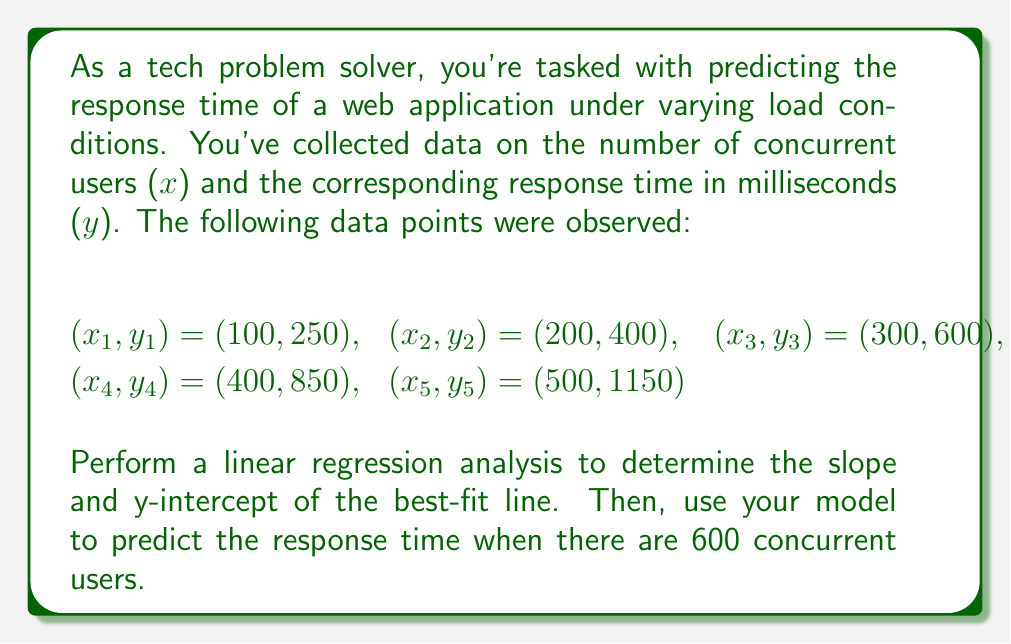What is the answer to this math problem? To perform linear regression, we'll use the least squares method to find the best-fit line $y = mx + b$, where $m$ is the slope and $b$ is the y-intercept.

Step 1: Calculate the means of x and y
$$\bar{x} = \frac{100 + 200 + 300 + 400 + 500}{5} = 300$$
$$\bar{y} = \frac{250 + 400 + 600 + 850 + 1150}{5} = 650$$

Step 2: Calculate the slope (m)
$$m = \frac{\sum(x_i - \bar{x})(y_i - \bar{y})}{\sum(x_i - \bar{x})^2}$$

Calculate the numerator and denominator:
$$(100 - 300)(250 - 650) + (200 - 300)(400 - 650) + (300 - 300)(600 - 650) + (400 - 300)(850 - 650) + (500 - 300)(1150 - 650)$$
$$= 80000 + 25000 + 0 + 40000 + 100000 = 245000$$

$$(100 - 300)^2 + (200 - 300)^2 + (300 - 300)^2 + (400 - 300)^2 + (500 - 300)^2$$
$$= 40000 + 10000 + 0 + 10000 + 40000 = 100000$$

$$m = \frac{245000}{100000} = 2.45$$

Step 3: Calculate the y-intercept (b)
$$b = \bar{y} - m\bar{x} = 650 - 2.45(300) = -85$$

Step 4: Write the equation of the best-fit line
$$y = 2.45x - 85$$

Step 5: Predict the response time for 600 concurrent users
$$y = 2.45(600) - 85 = 1385$$

Therefore, the predicted response time for 600 concurrent users is 1385 milliseconds.
Answer: $y = 2.45x - 85$; 1385 ms 